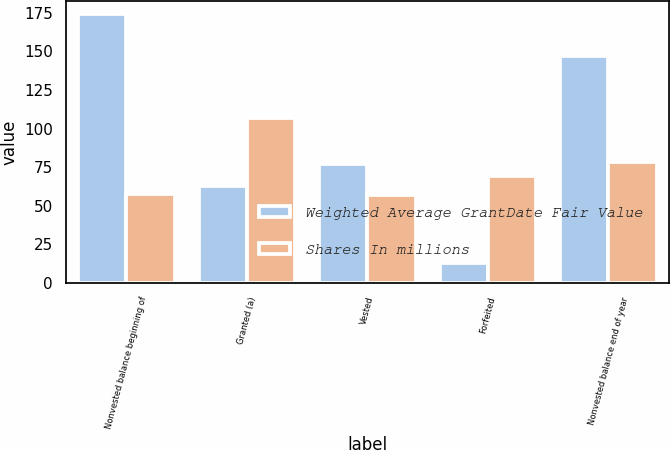<chart> <loc_0><loc_0><loc_500><loc_500><stacked_bar_chart><ecel><fcel>Nonvested balance beginning of<fcel>Granted (a)<fcel>Vested<fcel>Forfeited<fcel>Nonvested balance end of year<nl><fcel>Weighted Average GrantDate Fair Value<fcel>174<fcel>63<fcel>77<fcel>13<fcel>147<nl><fcel>Shares In millions<fcel>57.85<fcel>107.02<fcel>57.08<fcel>69.35<fcel>78.49<nl></chart> 